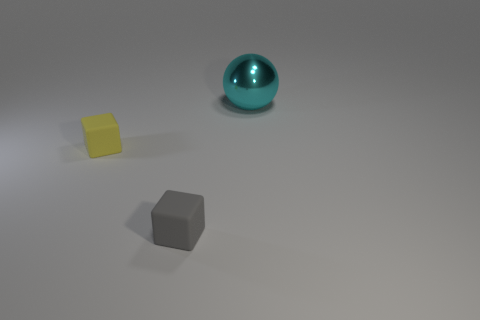Is the size of the metal ball the same as the thing that is on the left side of the tiny gray matte cube? No, the size of the metal ball is not the same as the object on the left side of the tiny gray matte cube. The metal ball appears larger than the small yellowish object, which could be a cube or block, positioned to the left of the gray cube. 